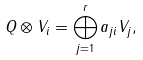<formula> <loc_0><loc_0><loc_500><loc_500>Q \otimes V _ { i } = \bigoplus _ { j = 1 } ^ { r } a _ { j i } V _ { j } ,</formula> 